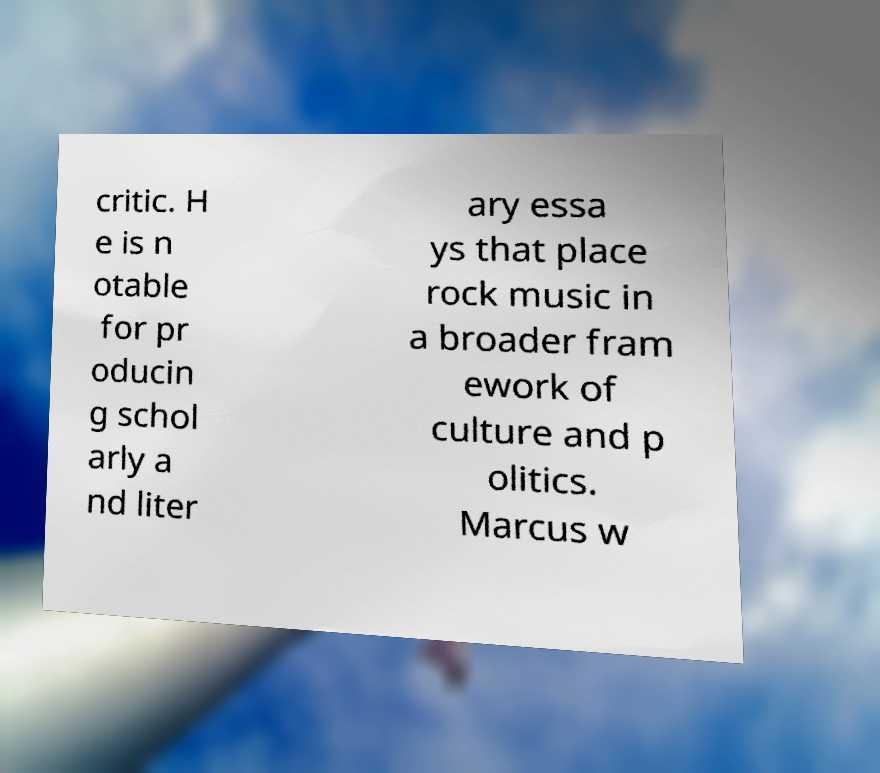Can you read and provide the text displayed in the image?This photo seems to have some interesting text. Can you extract and type it out for me? critic. H e is n otable for pr oducin g schol arly a nd liter ary essa ys that place rock music in a broader fram ework of culture and p olitics. Marcus w 